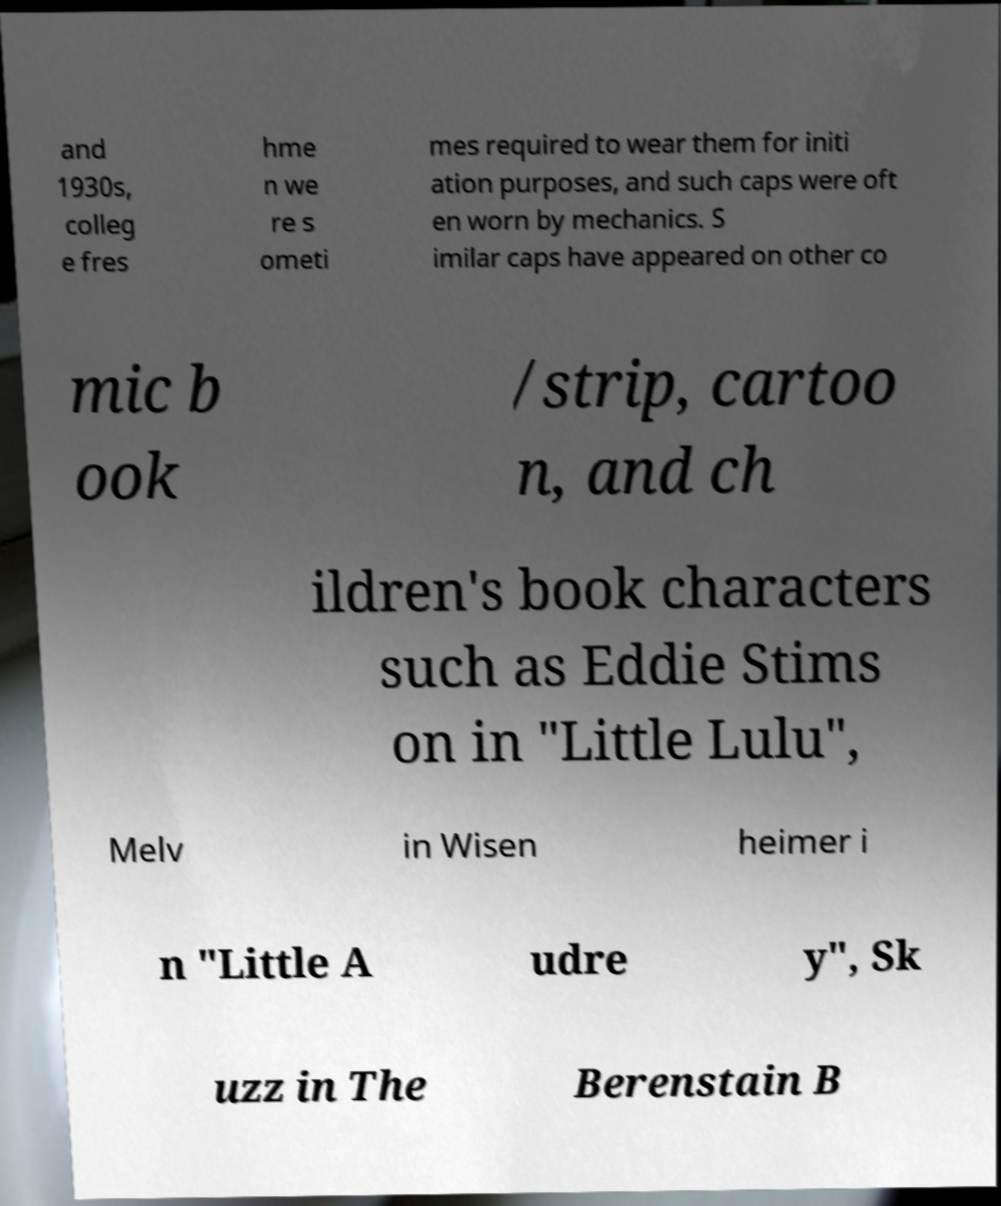Could you extract and type out the text from this image? and 1930s, colleg e fres hme n we re s ometi mes required to wear them for initi ation purposes, and such caps were oft en worn by mechanics. S imilar caps have appeared on other co mic b ook /strip, cartoo n, and ch ildren's book characters such as Eddie Stims on in "Little Lulu", Melv in Wisen heimer i n "Little A udre y", Sk uzz in The Berenstain B 